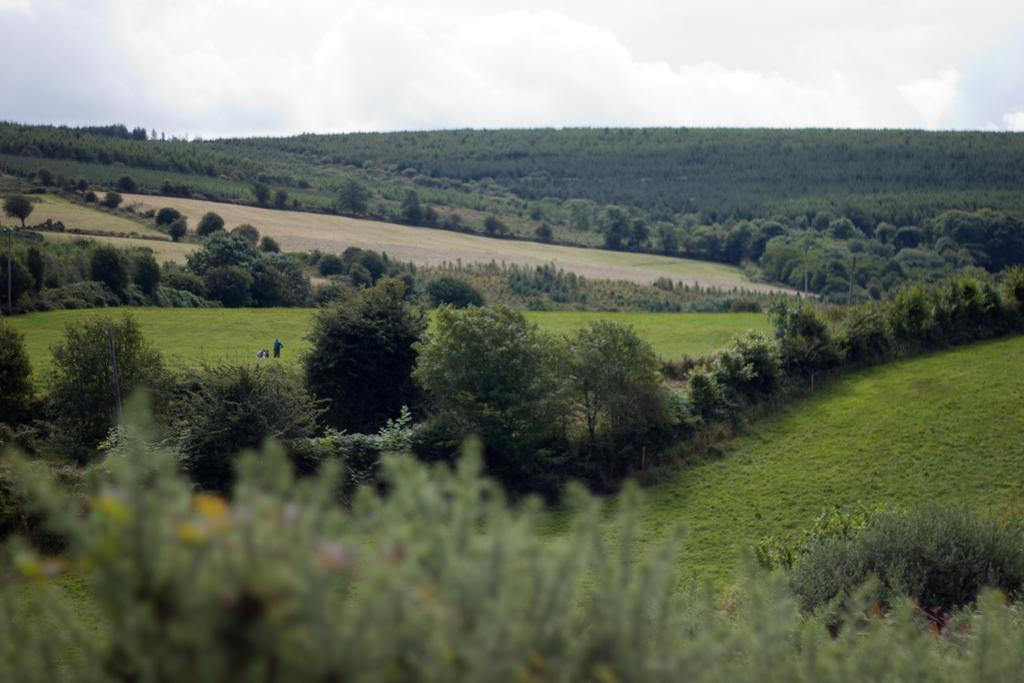What is the main feature in the foreground of the image? There is a field in the foreground of the image. Can you describe the person's position in the image? There appears to be a person on the left side of the image. What can be seen in the background of the image? There are mountains and the sky visible in the background of the image. What type of key is the person holding in the image? There is no key visible in the image; the person is not holding anything. 